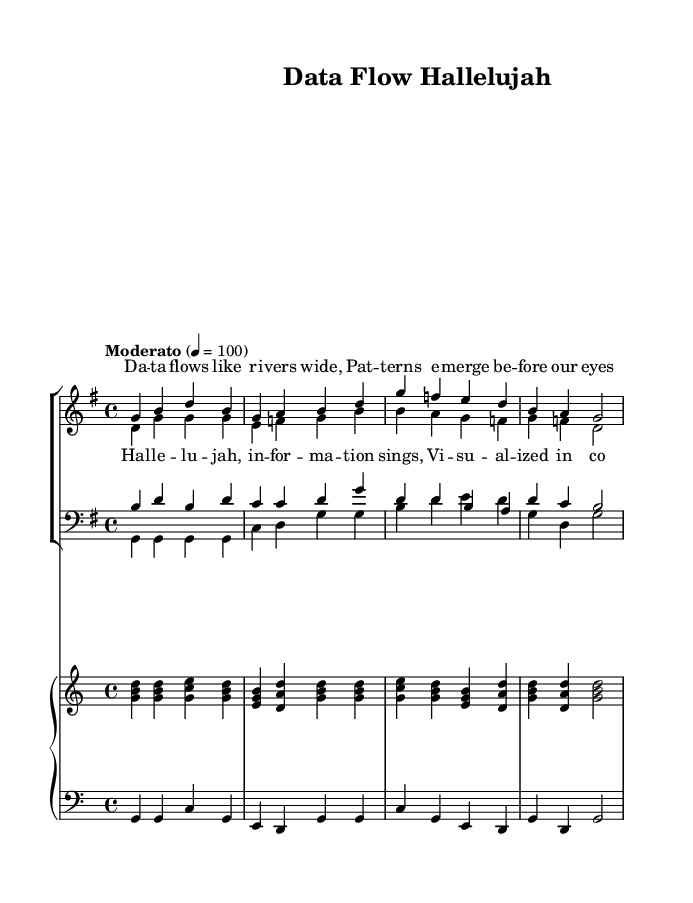What is the key signature of this music? The key signature is G major, which has one sharp, specifically F-sharp. This is indicated by the key signature notation at the beginning of the staff.
Answer: G major What is the time signature of this music? The time signature is 4/4, meaning there are four beats in each measure and a quarter note receives one beat. This is noted at the beginning of the score right after the key signature.
Answer: 4/4 What is the tempo marking for this piece? The tempo marking is "Moderato" with a metronome setting of 100 beats per minute. This indicates the speed at which the piece should be played. It is found at the beginning of the score.
Answer: Moderato How many vocal parts are present in this arrangement? There are four vocal parts: sopranos, altos, tenors, and basses. This is evident from the choir staff layout shown in the score, which includes separate staves for each vocal group.
Answer: Four What is the primary lyrical theme in the chorus? The lyrical theme in the chorus focuses on "Hallelujah" and information being visualized in bright colors. Analyzing the chorus section reveals the repeated phrase that emphasizes this theme.
Answer: Hallelujah Which instruments accompany the choir in this arrangement? The instruments that accompany the choir are the piano, as indicated by the presence of a piano staff in the score with both right-hand and left-hand parts. The score layout explicitly depicts this accompaniment.
Answer: Piano What vocal range does the soprano part typically cover? The soprano part in this arrangement covers a range starting from G above middle C to D several octaves above, indicated by the pitches written in the sopranoNotes section. This is typical for soprano voice parts.
Answer: G to D 